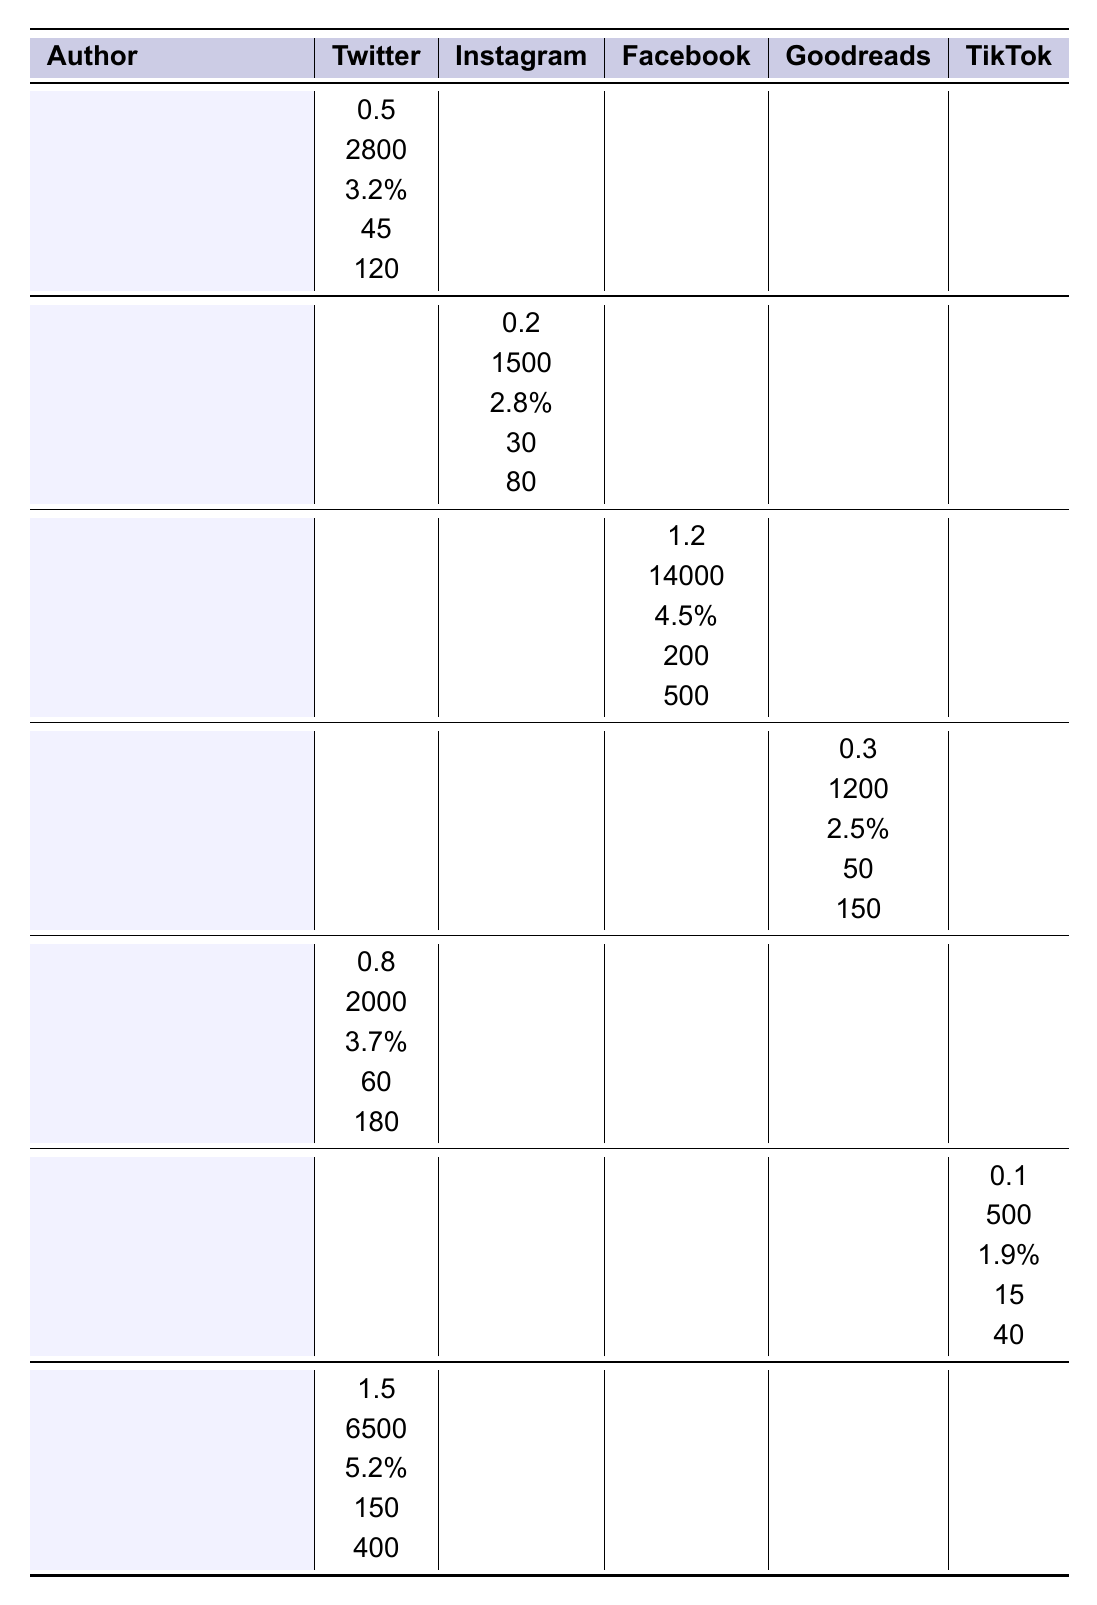What is the average engagement rate for the authors listed? To calculate the average engagement rate, we add up all the engagement rates: 3.2 + 2.8 + 4.5 + 2.5 + 3.7 + 1.9 + 5.2 = 23.8. There are 7 authors, so we divide 23.8 by 7, resulting in approximately 3.4%.
Answer: 3.4% Which author has the highest follower count on Facebook? By checking the Facebook follower counts, J.K. Rowling has 14,000 followers, which is the highest among all authors.
Answer: J.K. Rowling How many average daily posts does Stephen King make on Twitter? Stephen King is recorded as making 1.5 average daily posts on Twitter based on the table.
Answer: 1.5 Does Neil Gaiman have more shares per post on Instagram or TikTok? Neil Gaiman has no shares per post listed for Instagram, while for TikTok, he has 120 shares per post. Therefore, he has more shares on TikTok than on Instagram.
Answer: Yes, more on TikTok What is the total follower count across all platforms for Kazuo Ishiguro? Kazuo Ishiguro has 500 followers on Facebook, and 0 on other platforms (as the data shows). Thus, total follower count is 500.
Answer: 500 Which platform shows the highest engagement rate for any author? Looking at the engagement rates, Stephen King has the highest at 5.2% on TikTok.
Answer: 5.2% Is there any author that does not post on Instagram? From the data, it shows that George R.R. Martin and Kazuo Ishiguro have no data listed for Instagram, meaning they do not post there.
Answer: Yes, two authors If we sum the average daily posts of all authors, what is the total? Adding their daily posts: 0.5 + 0.2 + 1.2 + 0.3 + 0.8 + 0.1 + 1.5 = 4.6 total average daily posts.
Answer: 4.6 Which author has the lowest engagement rate, and what is it? Reviewing the engagement rates, Kazuo Ishiguro has the lowest at 1.9%.
Answer: Kazuo Ishiguro, 1.9% Between Haruki Murakami and Margaret Atwood, who has a higher average daily post count? Haruki Murakami has 0.2 average daily posts, while Margaret Atwood has 0.8. Therefore, Margaret Atwood has the higher count.
Answer: Margaret Atwood What is the difference in shares per post between J.K. Rowling and George R.R. Martin? J.K. Rowling has 500 shares per post, while George R.R. Martin has 150. The difference is 500 - 150 = 350 shares.
Answer: 350 shares 